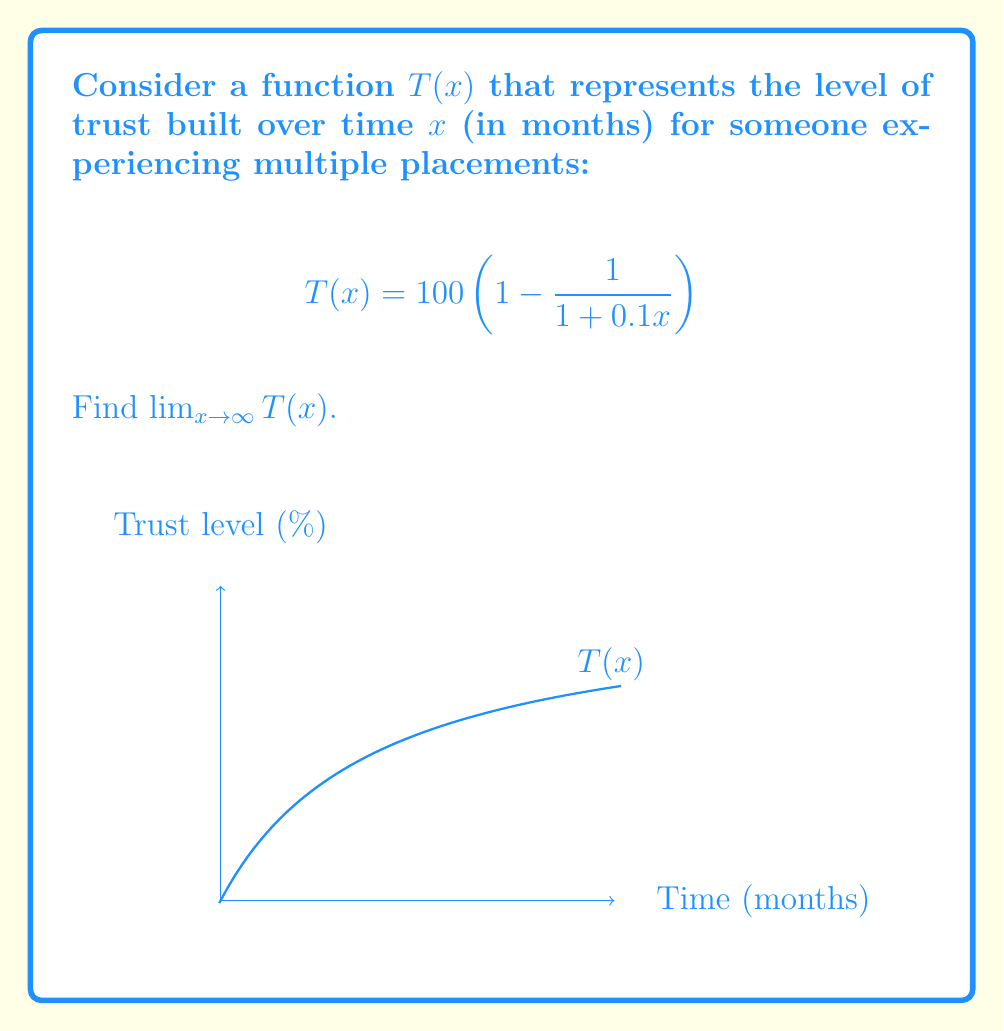Teach me how to tackle this problem. Let's approach this step-by-step:

1) We need to evaluate $\lim_{x \to \infty} 100 \left(1 - \frac{1}{1 + 0.1x}\right)$

2) As $x$ approaches infinity, $0.1x$ also approaches infinity.

3) Let's focus on the fraction $\frac{1}{1 + 0.1x}$:
   As $x \to \infty$, $1 + 0.1x \to \infty$, so $\frac{1}{1 + 0.1x} \to 0$

4) Therefore, $1 - \frac{1}{1 + 0.1x} \to 1 - 0 = 1$ as $x \to \infty$

5) Multiplying by 100:
   $\lim_{x \to \infty} 100 \left(1 - \frac{1}{1 + 0.1x}\right) = 100 \cdot 1 = 100$

This result suggests that as time goes to infinity, the trust level approaches 100%, indicating that with enough time, full trust can potentially be built.
Answer: 100 